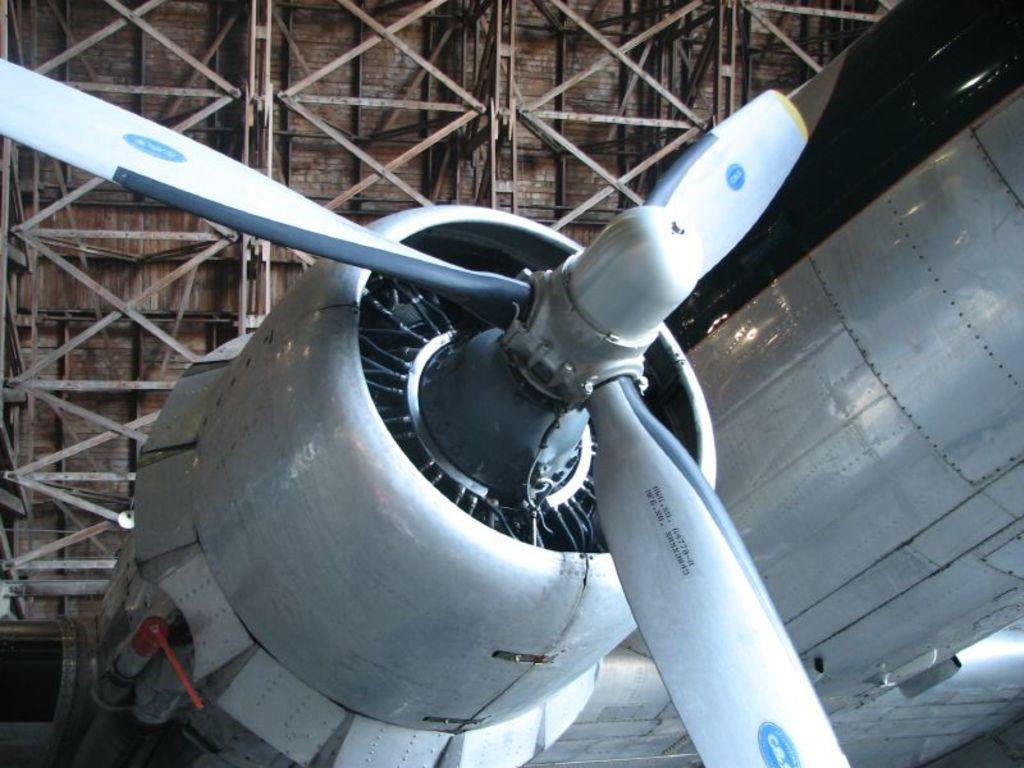Describe this image in one or two sentences. In the picture we can see a part of an aircraft engine with a fan and behind it, we can see the ceiling with iron rods to it. 